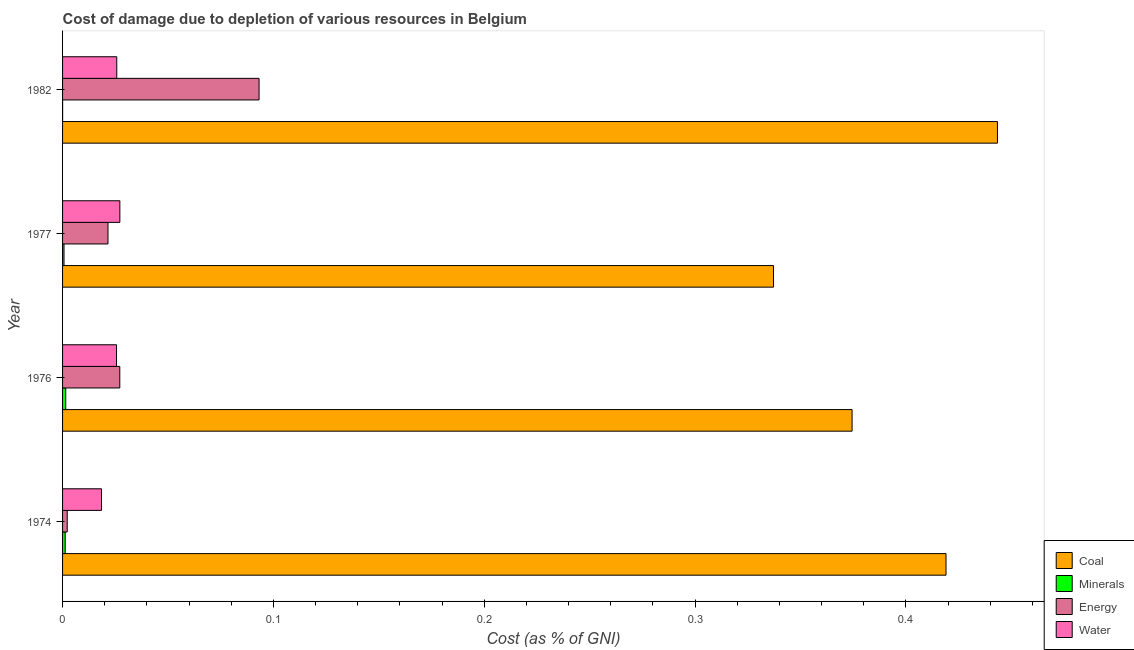How many different coloured bars are there?
Provide a short and direct response. 4. How many groups of bars are there?
Your answer should be very brief. 4. Are the number of bars on each tick of the Y-axis equal?
Offer a terse response. Yes. How many bars are there on the 1st tick from the bottom?
Provide a short and direct response. 4. What is the label of the 4th group of bars from the top?
Your response must be concise. 1974. In how many cases, is the number of bars for a given year not equal to the number of legend labels?
Offer a terse response. 0. What is the cost of damage due to depletion of minerals in 1976?
Offer a terse response. 0. Across all years, what is the maximum cost of damage due to depletion of minerals?
Ensure brevity in your answer.  0. Across all years, what is the minimum cost of damage due to depletion of water?
Your answer should be compact. 0.02. In which year was the cost of damage due to depletion of water maximum?
Keep it short and to the point. 1977. In which year was the cost of damage due to depletion of water minimum?
Offer a very short reply. 1974. What is the total cost of damage due to depletion of minerals in the graph?
Give a very brief answer. 0. What is the difference between the cost of damage due to depletion of coal in 1976 and that in 1977?
Your response must be concise. 0.04. What is the difference between the cost of damage due to depletion of water in 1976 and the cost of damage due to depletion of energy in 1982?
Your response must be concise. -0.07. What is the average cost of damage due to depletion of coal per year?
Make the answer very short. 0.39. In the year 1974, what is the difference between the cost of damage due to depletion of coal and cost of damage due to depletion of water?
Your answer should be compact. 0.4. In how many years, is the cost of damage due to depletion of water greater than 0.08 %?
Provide a short and direct response. 0. What is the ratio of the cost of damage due to depletion of energy in 1976 to that in 1982?
Ensure brevity in your answer.  0.29. Is the difference between the cost of damage due to depletion of water in 1974 and 1977 greater than the difference between the cost of damage due to depletion of coal in 1974 and 1977?
Offer a very short reply. No. What is the difference between the highest and the second highest cost of damage due to depletion of energy?
Your answer should be very brief. 0.07. What is the difference between the highest and the lowest cost of damage due to depletion of energy?
Give a very brief answer. 0.09. Is the sum of the cost of damage due to depletion of water in 1974 and 1982 greater than the maximum cost of damage due to depletion of minerals across all years?
Your answer should be very brief. Yes. Is it the case that in every year, the sum of the cost of damage due to depletion of minerals and cost of damage due to depletion of water is greater than the sum of cost of damage due to depletion of coal and cost of damage due to depletion of energy?
Your answer should be compact. No. What does the 4th bar from the top in 1982 represents?
Provide a succinct answer. Coal. What does the 3rd bar from the bottom in 1977 represents?
Your answer should be very brief. Energy. How many bars are there?
Your answer should be compact. 16. How many years are there in the graph?
Your answer should be compact. 4. What is the difference between two consecutive major ticks on the X-axis?
Keep it short and to the point. 0.1. Does the graph contain any zero values?
Give a very brief answer. No. Does the graph contain grids?
Your response must be concise. No. Where does the legend appear in the graph?
Offer a terse response. Bottom right. How many legend labels are there?
Provide a short and direct response. 4. What is the title of the graph?
Keep it short and to the point. Cost of damage due to depletion of various resources in Belgium . What is the label or title of the X-axis?
Your response must be concise. Cost (as % of GNI). What is the label or title of the Y-axis?
Provide a short and direct response. Year. What is the Cost (as % of GNI) in Coal in 1974?
Make the answer very short. 0.42. What is the Cost (as % of GNI) in Minerals in 1974?
Provide a short and direct response. 0. What is the Cost (as % of GNI) in Energy in 1974?
Keep it short and to the point. 0. What is the Cost (as % of GNI) of Water in 1974?
Keep it short and to the point. 0.02. What is the Cost (as % of GNI) of Coal in 1976?
Provide a succinct answer. 0.37. What is the Cost (as % of GNI) of Minerals in 1976?
Provide a short and direct response. 0. What is the Cost (as % of GNI) in Energy in 1976?
Provide a succinct answer. 0.03. What is the Cost (as % of GNI) of Water in 1976?
Give a very brief answer. 0.03. What is the Cost (as % of GNI) in Coal in 1977?
Provide a succinct answer. 0.34. What is the Cost (as % of GNI) in Minerals in 1977?
Your answer should be compact. 0. What is the Cost (as % of GNI) of Energy in 1977?
Your answer should be very brief. 0.02. What is the Cost (as % of GNI) of Water in 1977?
Offer a very short reply. 0.03. What is the Cost (as % of GNI) of Coal in 1982?
Your response must be concise. 0.44. What is the Cost (as % of GNI) of Minerals in 1982?
Provide a succinct answer. 2.31292813019687e-5. What is the Cost (as % of GNI) of Energy in 1982?
Your answer should be compact. 0.09. What is the Cost (as % of GNI) in Water in 1982?
Provide a short and direct response. 0.03. Across all years, what is the maximum Cost (as % of GNI) of Coal?
Ensure brevity in your answer.  0.44. Across all years, what is the maximum Cost (as % of GNI) of Minerals?
Your answer should be very brief. 0. Across all years, what is the maximum Cost (as % of GNI) of Energy?
Provide a short and direct response. 0.09. Across all years, what is the maximum Cost (as % of GNI) of Water?
Your response must be concise. 0.03. Across all years, what is the minimum Cost (as % of GNI) in Coal?
Your answer should be compact. 0.34. Across all years, what is the minimum Cost (as % of GNI) in Minerals?
Make the answer very short. 2.31292813019687e-5. Across all years, what is the minimum Cost (as % of GNI) in Energy?
Your answer should be very brief. 0. Across all years, what is the minimum Cost (as % of GNI) in Water?
Your answer should be very brief. 0.02. What is the total Cost (as % of GNI) of Coal in the graph?
Offer a terse response. 1.57. What is the total Cost (as % of GNI) of Minerals in the graph?
Ensure brevity in your answer.  0. What is the total Cost (as % of GNI) in Energy in the graph?
Your answer should be compact. 0.14. What is the total Cost (as % of GNI) in Water in the graph?
Your answer should be compact. 0.1. What is the difference between the Cost (as % of GNI) of Coal in 1974 and that in 1976?
Provide a succinct answer. 0.04. What is the difference between the Cost (as % of GNI) of Minerals in 1974 and that in 1976?
Keep it short and to the point. -0. What is the difference between the Cost (as % of GNI) in Energy in 1974 and that in 1976?
Make the answer very short. -0.02. What is the difference between the Cost (as % of GNI) of Water in 1974 and that in 1976?
Give a very brief answer. -0.01. What is the difference between the Cost (as % of GNI) of Coal in 1974 and that in 1977?
Your answer should be very brief. 0.08. What is the difference between the Cost (as % of GNI) in Minerals in 1974 and that in 1977?
Provide a succinct answer. 0. What is the difference between the Cost (as % of GNI) in Energy in 1974 and that in 1977?
Your answer should be compact. -0.02. What is the difference between the Cost (as % of GNI) in Water in 1974 and that in 1977?
Ensure brevity in your answer.  -0.01. What is the difference between the Cost (as % of GNI) in Coal in 1974 and that in 1982?
Keep it short and to the point. -0.02. What is the difference between the Cost (as % of GNI) in Minerals in 1974 and that in 1982?
Give a very brief answer. 0. What is the difference between the Cost (as % of GNI) in Energy in 1974 and that in 1982?
Provide a succinct answer. -0.09. What is the difference between the Cost (as % of GNI) of Water in 1974 and that in 1982?
Make the answer very short. -0.01. What is the difference between the Cost (as % of GNI) of Coal in 1976 and that in 1977?
Provide a succinct answer. 0.04. What is the difference between the Cost (as % of GNI) of Minerals in 1976 and that in 1977?
Provide a short and direct response. 0. What is the difference between the Cost (as % of GNI) of Energy in 1976 and that in 1977?
Keep it short and to the point. 0.01. What is the difference between the Cost (as % of GNI) of Water in 1976 and that in 1977?
Give a very brief answer. -0. What is the difference between the Cost (as % of GNI) of Coal in 1976 and that in 1982?
Ensure brevity in your answer.  -0.07. What is the difference between the Cost (as % of GNI) of Minerals in 1976 and that in 1982?
Ensure brevity in your answer.  0. What is the difference between the Cost (as % of GNI) in Energy in 1976 and that in 1982?
Your response must be concise. -0.07. What is the difference between the Cost (as % of GNI) in Water in 1976 and that in 1982?
Your answer should be very brief. -0. What is the difference between the Cost (as % of GNI) in Coal in 1977 and that in 1982?
Your answer should be very brief. -0.11. What is the difference between the Cost (as % of GNI) of Minerals in 1977 and that in 1982?
Keep it short and to the point. 0. What is the difference between the Cost (as % of GNI) in Energy in 1977 and that in 1982?
Offer a very short reply. -0.07. What is the difference between the Cost (as % of GNI) in Water in 1977 and that in 1982?
Make the answer very short. 0. What is the difference between the Cost (as % of GNI) of Coal in 1974 and the Cost (as % of GNI) of Minerals in 1976?
Provide a short and direct response. 0.42. What is the difference between the Cost (as % of GNI) in Coal in 1974 and the Cost (as % of GNI) in Energy in 1976?
Keep it short and to the point. 0.39. What is the difference between the Cost (as % of GNI) in Coal in 1974 and the Cost (as % of GNI) in Water in 1976?
Ensure brevity in your answer.  0.39. What is the difference between the Cost (as % of GNI) in Minerals in 1974 and the Cost (as % of GNI) in Energy in 1976?
Keep it short and to the point. -0.03. What is the difference between the Cost (as % of GNI) in Minerals in 1974 and the Cost (as % of GNI) in Water in 1976?
Make the answer very short. -0.02. What is the difference between the Cost (as % of GNI) in Energy in 1974 and the Cost (as % of GNI) in Water in 1976?
Ensure brevity in your answer.  -0.02. What is the difference between the Cost (as % of GNI) of Coal in 1974 and the Cost (as % of GNI) of Minerals in 1977?
Provide a short and direct response. 0.42. What is the difference between the Cost (as % of GNI) of Coal in 1974 and the Cost (as % of GNI) of Energy in 1977?
Offer a very short reply. 0.4. What is the difference between the Cost (as % of GNI) of Coal in 1974 and the Cost (as % of GNI) of Water in 1977?
Ensure brevity in your answer.  0.39. What is the difference between the Cost (as % of GNI) in Minerals in 1974 and the Cost (as % of GNI) in Energy in 1977?
Make the answer very short. -0.02. What is the difference between the Cost (as % of GNI) of Minerals in 1974 and the Cost (as % of GNI) of Water in 1977?
Your response must be concise. -0.03. What is the difference between the Cost (as % of GNI) of Energy in 1974 and the Cost (as % of GNI) of Water in 1977?
Keep it short and to the point. -0.03. What is the difference between the Cost (as % of GNI) in Coal in 1974 and the Cost (as % of GNI) in Minerals in 1982?
Offer a very short reply. 0.42. What is the difference between the Cost (as % of GNI) in Coal in 1974 and the Cost (as % of GNI) in Energy in 1982?
Provide a succinct answer. 0.33. What is the difference between the Cost (as % of GNI) of Coal in 1974 and the Cost (as % of GNI) of Water in 1982?
Give a very brief answer. 0.39. What is the difference between the Cost (as % of GNI) in Minerals in 1974 and the Cost (as % of GNI) in Energy in 1982?
Ensure brevity in your answer.  -0.09. What is the difference between the Cost (as % of GNI) in Minerals in 1974 and the Cost (as % of GNI) in Water in 1982?
Ensure brevity in your answer.  -0.02. What is the difference between the Cost (as % of GNI) in Energy in 1974 and the Cost (as % of GNI) in Water in 1982?
Your answer should be compact. -0.02. What is the difference between the Cost (as % of GNI) in Coal in 1976 and the Cost (as % of GNI) in Minerals in 1977?
Ensure brevity in your answer.  0.37. What is the difference between the Cost (as % of GNI) in Coal in 1976 and the Cost (as % of GNI) in Energy in 1977?
Your answer should be very brief. 0.35. What is the difference between the Cost (as % of GNI) in Coal in 1976 and the Cost (as % of GNI) in Water in 1977?
Ensure brevity in your answer.  0.35. What is the difference between the Cost (as % of GNI) of Minerals in 1976 and the Cost (as % of GNI) of Energy in 1977?
Make the answer very short. -0.02. What is the difference between the Cost (as % of GNI) in Minerals in 1976 and the Cost (as % of GNI) in Water in 1977?
Your answer should be compact. -0.03. What is the difference between the Cost (as % of GNI) in Coal in 1976 and the Cost (as % of GNI) in Minerals in 1982?
Your response must be concise. 0.37. What is the difference between the Cost (as % of GNI) of Coal in 1976 and the Cost (as % of GNI) of Energy in 1982?
Your answer should be compact. 0.28. What is the difference between the Cost (as % of GNI) in Coal in 1976 and the Cost (as % of GNI) in Water in 1982?
Provide a short and direct response. 0.35. What is the difference between the Cost (as % of GNI) in Minerals in 1976 and the Cost (as % of GNI) in Energy in 1982?
Ensure brevity in your answer.  -0.09. What is the difference between the Cost (as % of GNI) of Minerals in 1976 and the Cost (as % of GNI) of Water in 1982?
Your response must be concise. -0.02. What is the difference between the Cost (as % of GNI) in Energy in 1976 and the Cost (as % of GNI) in Water in 1982?
Offer a terse response. 0. What is the difference between the Cost (as % of GNI) of Coal in 1977 and the Cost (as % of GNI) of Minerals in 1982?
Provide a short and direct response. 0.34. What is the difference between the Cost (as % of GNI) in Coal in 1977 and the Cost (as % of GNI) in Energy in 1982?
Provide a succinct answer. 0.24. What is the difference between the Cost (as % of GNI) of Coal in 1977 and the Cost (as % of GNI) of Water in 1982?
Make the answer very short. 0.31. What is the difference between the Cost (as % of GNI) of Minerals in 1977 and the Cost (as % of GNI) of Energy in 1982?
Provide a short and direct response. -0.09. What is the difference between the Cost (as % of GNI) in Minerals in 1977 and the Cost (as % of GNI) in Water in 1982?
Provide a succinct answer. -0.03. What is the difference between the Cost (as % of GNI) of Energy in 1977 and the Cost (as % of GNI) of Water in 1982?
Keep it short and to the point. -0. What is the average Cost (as % of GNI) of Coal per year?
Make the answer very short. 0.39. What is the average Cost (as % of GNI) of Minerals per year?
Provide a succinct answer. 0. What is the average Cost (as % of GNI) in Energy per year?
Keep it short and to the point. 0.04. What is the average Cost (as % of GNI) of Water per year?
Keep it short and to the point. 0.02. In the year 1974, what is the difference between the Cost (as % of GNI) of Coal and Cost (as % of GNI) of Minerals?
Keep it short and to the point. 0.42. In the year 1974, what is the difference between the Cost (as % of GNI) of Coal and Cost (as % of GNI) of Energy?
Offer a very short reply. 0.42. In the year 1974, what is the difference between the Cost (as % of GNI) of Coal and Cost (as % of GNI) of Water?
Offer a terse response. 0.4. In the year 1974, what is the difference between the Cost (as % of GNI) of Minerals and Cost (as % of GNI) of Energy?
Provide a succinct answer. -0. In the year 1974, what is the difference between the Cost (as % of GNI) of Minerals and Cost (as % of GNI) of Water?
Your response must be concise. -0.02. In the year 1974, what is the difference between the Cost (as % of GNI) in Energy and Cost (as % of GNI) in Water?
Your answer should be very brief. -0.02. In the year 1976, what is the difference between the Cost (as % of GNI) in Coal and Cost (as % of GNI) in Minerals?
Provide a succinct answer. 0.37. In the year 1976, what is the difference between the Cost (as % of GNI) in Coal and Cost (as % of GNI) in Energy?
Your answer should be compact. 0.35. In the year 1976, what is the difference between the Cost (as % of GNI) of Coal and Cost (as % of GNI) of Water?
Offer a terse response. 0.35. In the year 1976, what is the difference between the Cost (as % of GNI) of Minerals and Cost (as % of GNI) of Energy?
Offer a terse response. -0.03. In the year 1976, what is the difference between the Cost (as % of GNI) in Minerals and Cost (as % of GNI) in Water?
Your answer should be compact. -0.02. In the year 1976, what is the difference between the Cost (as % of GNI) in Energy and Cost (as % of GNI) in Water?
Provide a short and direct response. 0. In the year 1977, what is the difference between the Cost (as % of GNI) of Coal and Cost (as % of GNI) of Minerals?
Provide a short and direct response. 0.34. In the year 1977, what is the difference between the Cost (as % of GNI) in Coal and Cost (as % of GNI) in Energy?
Offer a very short reply. 0.32. In the year 1977, what is the difference between the Cost (as % of GNI) of Coal and Cost (as % of GNI) of Water?
Keep it short and to the point. 0.31. In the year 1977, what is the difference between the Cost (as % of GNI) of Minerals and Cost (as % of GNI) of Energy?
Give a very brief answer. -0.02. In the year 1977, what is the difference between the Cost (as % of GNI) in Minerals and Cost (as % of GNI) in Water?
Offer a very short reply. -0.03. In the year 1977, what is the difference between the Cost (as % of GNI) in Energy and Cost (as % of GNI) in Water?
Your answer should be very brief. -0.01. In the year 1982, what is the difference between the Cost (as % of GNI) of Coal and Cost (as % of GNI) of Minerals?
Your response must be concise. 0.44. In the year 1982, what is the difference between the Cost (as % of GNI) of Coal and Cost (as % of GNI) of Energy?
Make the answer very short. 0.35. In the year 1982, what is the difference between the Cost (as % of GNI) of Coal and Cost (as % of GNI) of Water?
Your response must be concise. 0.42. In the year 1982, what is the difference between the Cost (as % of GNI) of Minerals and Cost (as % of GNI) of Energy?
Your answer should be very brief. -0.09. In the year 1982, what is the difference between the Cost (as % of GNI) in Minerals and Cost (as % of GNI) in Water?
Provide a short and direct response. -0.03. In the year 1982, what is the difference between the Cost (as % of GNI) of Energy and Cost (as % of GNI) of Water?
Keep it short and to the point. 0.07. What is the ratio of the Cost (as % of GNI) in Coal in 1974 to that in 1976?
Offer a very short reply. 1.12. What is the ratio of the Cost (as % of GNI) of Minerals in 1974 to that in 1976?
Your answer should be very brief. 0.84. What is the ratio of the Cost (as % of GNI) in Energy in 1974 to that in 1976?
Ensure brevity in your answer.  0.08. What is the ratio of the Cost (as % of GNI) in Water in 1974 to that in 1976?
Offer a terse response. 0.72. What is the ratio of the Cost (as % of GNI) of Coal in 1974 to that in 1977?
Your answer should be compact. 1.24. What is the ratio of the Cost (as % of GNI) of Minerals in 1974 to that in 1977?
Offer a terse response. 1.82. What is the ratio of the Cost (as % of GNI) in Energy in 1974 to that in 1977?
Your answer should be compact. 0.1. What is the ratio of the Cost (as % of GNI) of Water in 1974 to that in 1977?
Provide a short and direct response. 0.68. What is the ratio of the Cost (as % of GNI) in Coal in 1974 to that in 1982?
Make the answer very short. 0.94. What is the ratio of the Cost (as % of GNI) in Minerals in 1974 to that in 1982?
Your answer should be compact. 54.15. What is the ratio of the Cost (as % of GNI) of Energy in 1974 to that in 1982?
Your answer should be compact. 0.02. What is the ratio of the Cost (as % of GNI) of Water in 1974 to that in 1982?
Offer a very short reply. 0.72. What is the ratio of the Cost (as % of GNI) of Coal in 1976 to that in 1977?
Your answer should be very brief. 1.11. What is the ratio of the Cost (as % of GNI) in Minerals in 1976 to that in 1977?
Offer a very short reply. 2.17. What is the ratio of the Cost (as % of GNI) of Energy in 1976 to that in 1977?
Offer a terse response. 1.26. What is the ratio of the Cost (as % of GNI) of Water in 1976 to that in 1977?
Give a very brief answer. 0.94. What is the ratio of the Cost (as % of GNI) of Coal in 1976 to that in 1982?
Give a very brief answer. 0.84. What is the ratio of the Cost (as % of GNI) in Minerals in 1976 to that in 1982?
Offer a very short reply. 64.57. What is the ratio of the Cost (as % of GNI) in Energy in 1976 to that in 1982?
Keep it short and to the point. 0.29. What is the ratio of the Cost (as % of GNI) of Coal in 1977 to that in 1982?
Make the answer very short. 0.76. What is the ratio of the Cost (as % of GNI) in Minerals in 1977 to that in 1982?
Offer a terse response. 29.73. What is the ratio of the Cost (as % of GNI) of Energy in 1977 to that in 1982?
Your response must be concise. 0.23. What is the ratio of the Cost (as % of GNI) of Water in 1977 to that in 1982?
Give a very brief answer. 1.06. What is the difference between the highest and the second highest Cost (as % of GNI) in Coal?
Offer a terse response. 0.02. What is the difference between the highest and the second highest Cost (as % of GNI) in Energy?
Offer a very short reply. 0.07. What is the difference between the highest and the second highest Cost (as % of GNI) of Water?
Give a very brief answer. 0. What is the difference between the highest and the lowest Cost (as % of GNI) in Coal?
Offer a terse response. 0.11. What is the difference between the highest and the lowest Cost (as % of GNI) in Minerals?
Make the answer very short. 0. What is the difference between the highest and the lowest Cost (as % of GNI) of Energy?
Offer a terse response. 0.09. What is the difference between the highest and the lowest Cost (as % of GNI) in Water?
Give a very brief answer. 0.01. 